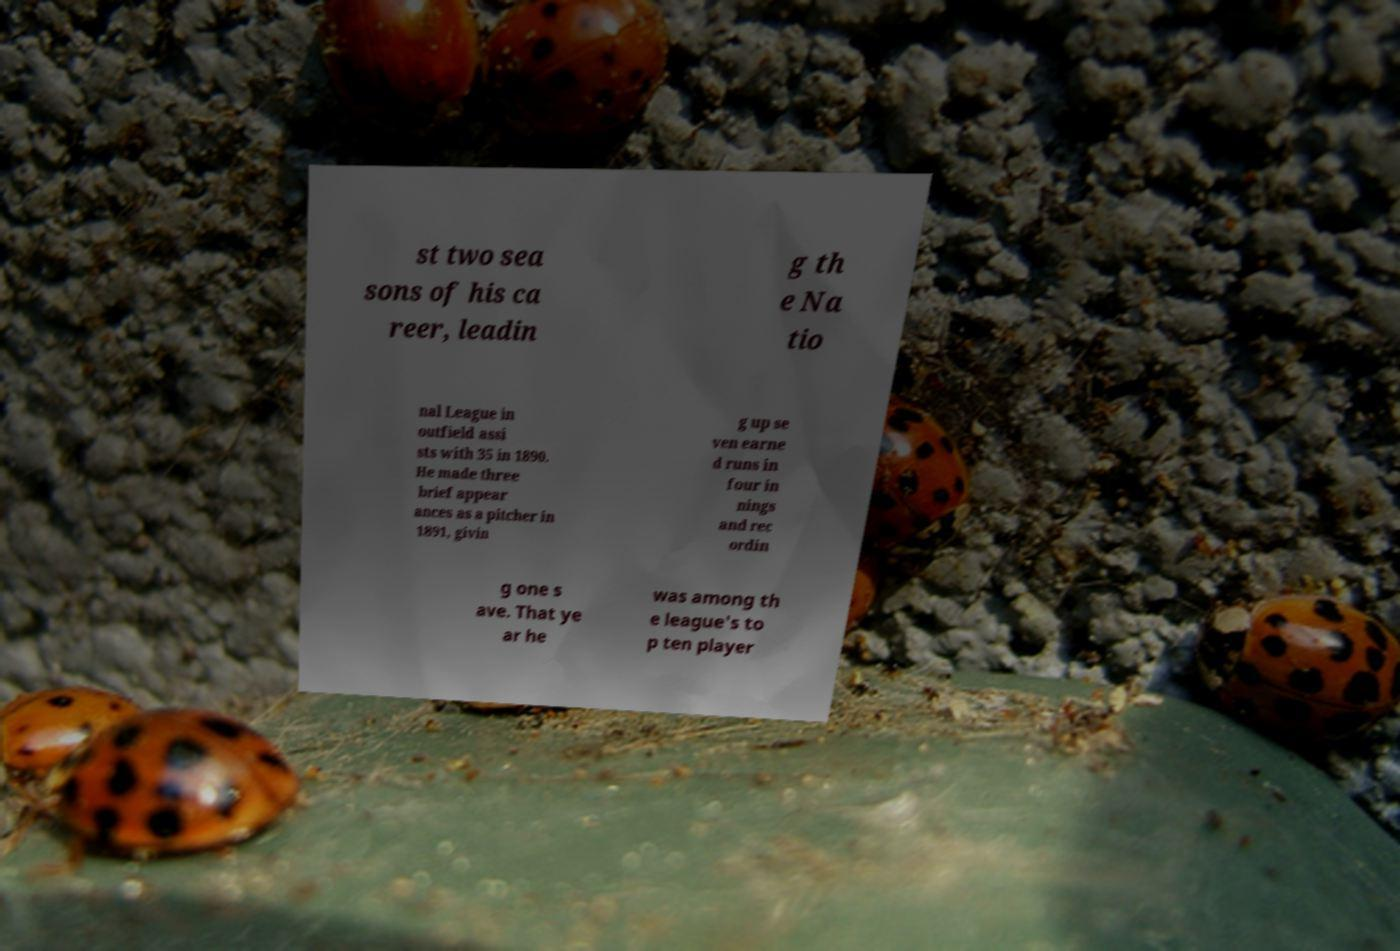There's text embedded in this image that I need extracted. Can you transcribe it verbatim? st two sea sons of his ca reer, leadin g th e Na tio nal League in outfield assi sts with 35 in 1890. He made three brief appear ances as a pitcher in 1891, givin g up se ven earne d runs in four in nings and rec ordin g one s ave. That ye ar he was among th e league's to p ten player 